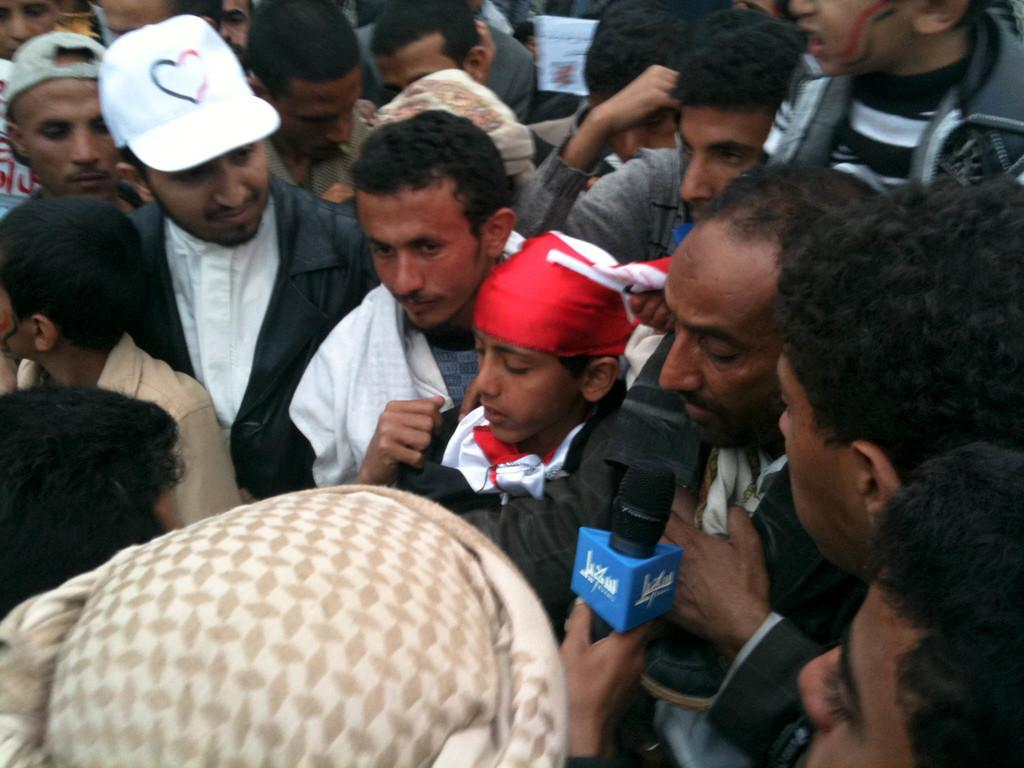What are the people in the image doing? The people in the image are standing. Can you describe the person in the front? The person in the front is holding a microphone. What can be observed about the clothing of the two persons on the left side? The two persons on the left side are wearing caps. How many girls are playing on the playground in the image? There is no playground or girls present in the image. What trick is the person in the front performing with the microphone? There is no trick being performed with the microphone in the image; the person is simply holding it. 